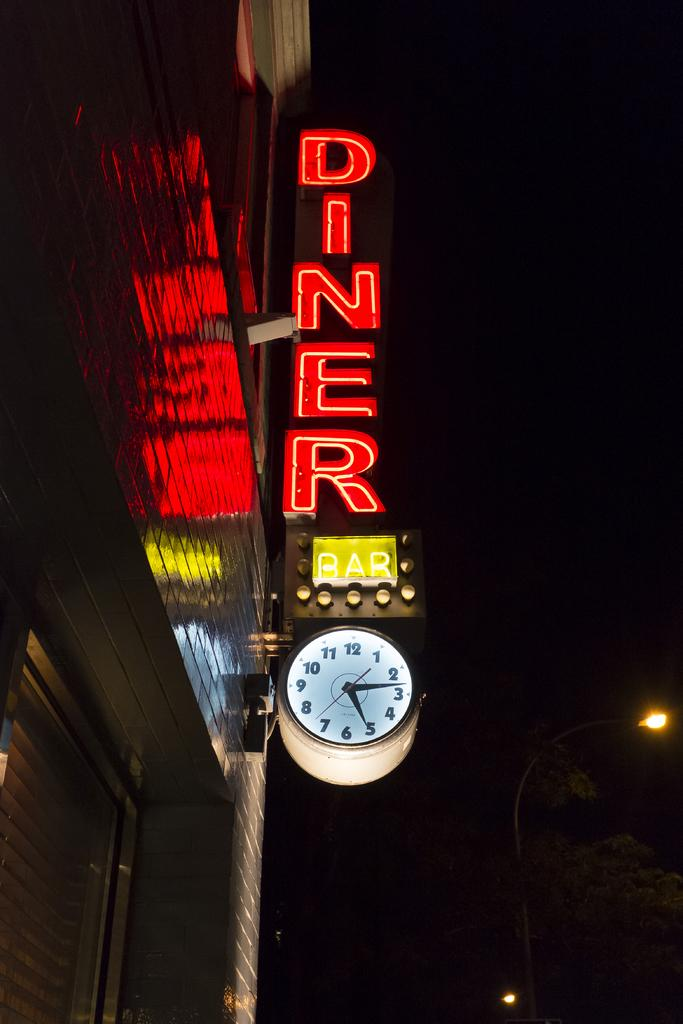<image>
Describe the image concisely. A neon sign lights up the exterior of a diner and bar. 